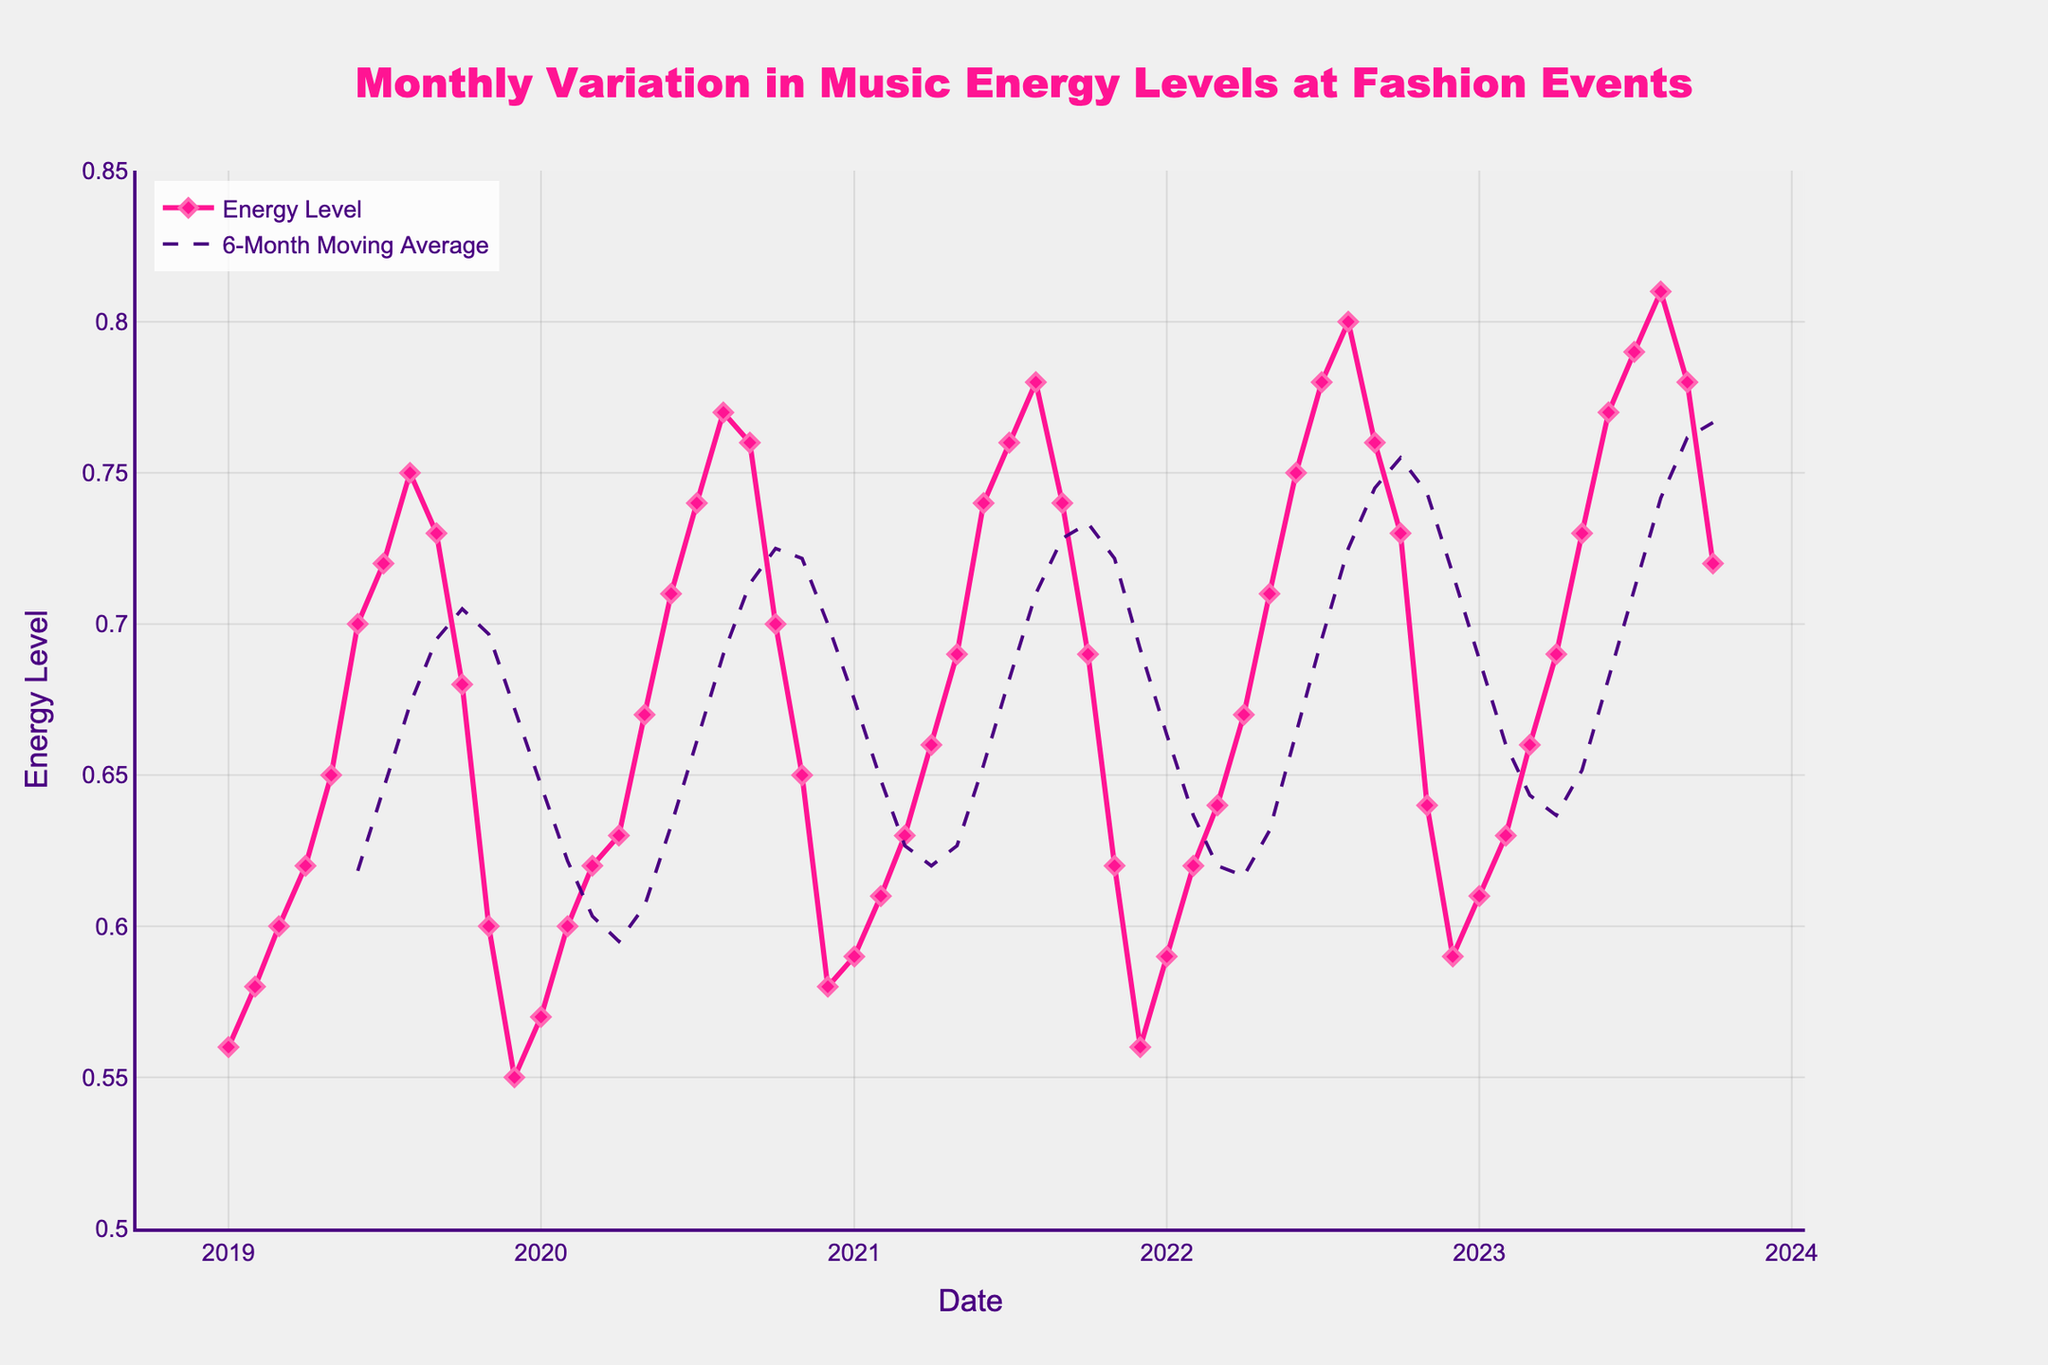What is the title of the figure? The title of the figure is prominently displayed at the top and reads "Monthly Variation in Music Energy Levels at Fashion Events".
Answer: Monthly Variation in Music Energy Levels at Fashion Events What is the energy level in December 2020? Locate December 2020 on the x-axis and trace the corresponding point on the energy level curve. The value is approximately 0.58.
Answer: 0.58 How does the energy level generally trend from January to August each year? Observing the plot, the energy level tends to increase from January to August each year. This is consistent across different years.
Answer: Increases What is the overall trend in energy levels over the last five years? The overall trend in energy levels over the last five years is an upward trend, as evidenced by the increasing values year-over-year and the upward slope of the moving average line.
Answer: Upward trend Which month and year had the highest energy level, and what was its value? Identify the peak point in the plot and see which month and year correspond to it. The highest energy level occurs in August 2023 with a value of approximately 0.81.
Answer: August 2023, 0.81 What is the difference in energy levels between July 2019 and October 2019? Find the energy levels for July 2019 (0.72) and October 2019 (0.68), then subtract October’s value from July’s value. The difference is 0.72 - 0.68 = 0.04.
Answer: 0.04 During which season does the energy level show the most significant increase? By breaking down the year into seasons and observing the changes, the energy level shows the most significant increase during the summer months (June, July, August).
Answer: Summer What is the trend of the 6-Month Moving Average line? The 6-Month Moving Average line shows a smoother upward trend compared to the individual monthly variations, indicating a general rise in the energy levels over time.
Answer: Upward trend Was there any point in the plot where the energy level decreased consistently over several months? Observing the plot closely, one can see that there are periods such as from September to December each year where the energy levels consistently decrease.
Answer: Yes, September to December How does the energy level in June 2021 compare to June 2023? Locate the energy levels for June 2021 (0.74) and June 2023 (0.77). Comparing the two, June 2023 has a higher energy level than June 2021.
Answer: June 2023 higher 